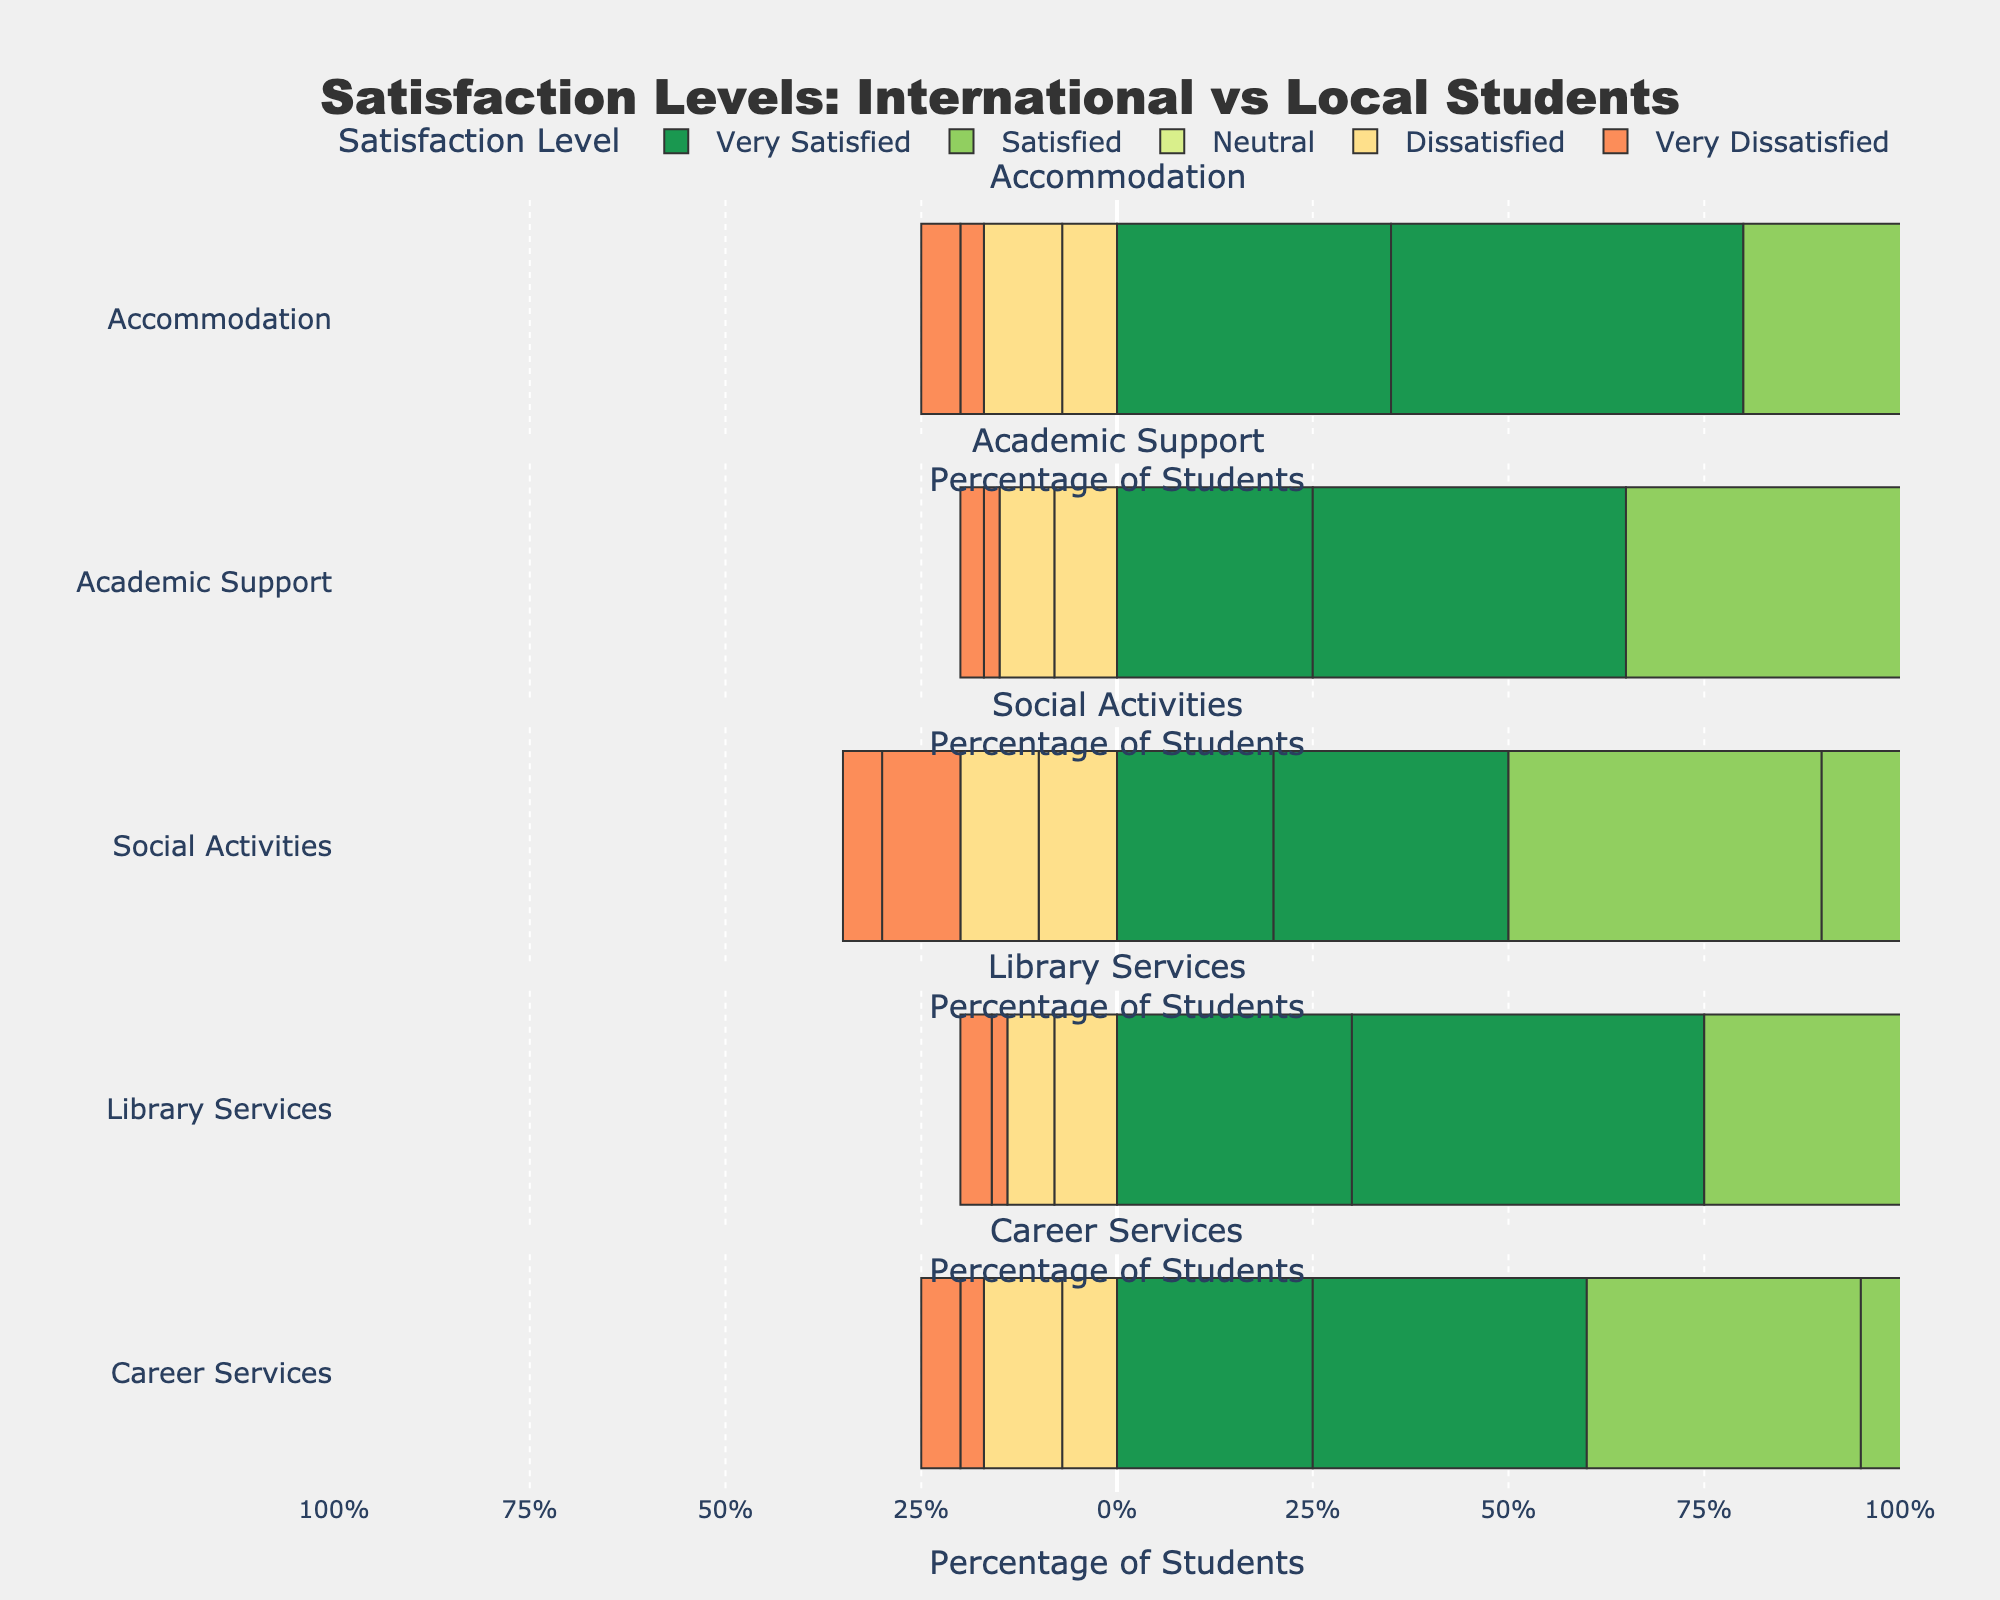Which service has the highest percentage of 'Very Dissatisfied' international students? Looking at the figure, the length of the bar for 'Very Dissatisfied' international students is longest for Social Activities.
Answer: Social Activities What is the difference in the number of 'Very Satisfied' students between international and local for Accommodation? For Accommodation, there are 35 'Very Satisfied' international students and 45 'Very Satisfied' local students. The difference is 45 - 35.
Answer: 10 Which satisfaction level has the highest combined total (international and local) for Academic Support? Summing the international and local students for each satisfaction level in Academic Support, 'Satisfied' has the highest combined total.
Answer: Satisfied What percentage of international students is 'Neutral' for Career Services? The total number of international students for Career Services is 100. There are 30 'Neutral' international students. The percentage is (30/100) * 100.
Answer: 30% Which service type has the smallest difference between 'Satisfied' international and local students? Examining the lengths of the bars representing 'Satisfied' students for each service type, Social Activities has the closest numbers (40 international vs. 35 local).
Answer: Social Activities In which service are local students most 'Dissatisfied' compared to international students? For all services, library services show the longest bar for 'Dissatisfied' local students compared to 'Dissatisfied' international students (10 vs. 8).
Answer: Career Services Which category has the most similar distribution of 'Very Satisfied' responses between international and local students? In Library Services, both international (30) and local (45) students share certain proportions across the entire service.
Answer: Library Services How many total international students are 'Dissatisfied' with Accommodation, Academic Support, and Social Activities combined? Adding up the 'Dissatisfied' international students from Accommodation (7), Academic Support (8), and Social Activities (10).
Answer: 25 Which satisfaction level does not differ between international and local students for Social Activities? In Social Activities, the number of 'Neutral' students for both international (20) and local (20) is the same.
Answer: Neutral 